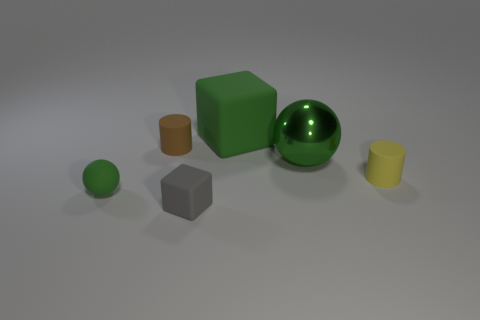There is a sphere that is in front of the yellow thing; how many metal objects are in front of it?
Your answer should be very brief. 0. Is the number of brown matte cylinders that are on the right side of the brown cylinder greater than the number of tiny brown cylinders?
Offer a very short reply. No. What size is the thing that is both on the right side of the tiny green matte sphere and in front of the yellow matte cylinder?
Your answer should be very brief. Small. What is the shape of the rubber thing that is both to the right of the tiny brown rubber thing and to the left of the green rubber block?
Give a very brief answer. Cube. There is a rubber block that is in front of the small object that is right of the large block; is there a rubber sphere on the right side of it?
Ensure brevity in your answer.  No. How many things are either tiny yellow rubber cylinders that are in front of the green block or green things behind the tiny yellow rubber object?
Give a very brief answer. 3. Is the material of the sphere that is behind the matte ball the same as the large cube?
Make the answer very short. No. There is a green thing that is right of the small green rubber ball and in front of the brown rubber cylinder; what is it made of?
Provide a short and direct response. Metal. There is a object that is behind the matte cylinder that is to the left of the tiny gray rubber object; what color is it?
Your response must be concise. Green. What material is the other green thing that is the same shape as the small green rubber object?
Your response must be concise. Metal. 